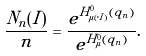Convert formula to latex. <formula><loc_0><loc_0><loc_500><loc_500>\frac { N _ { n } ( I ) } { n } = \frac { e ^ { H ^ { 0 } _ { \mu ( \cdot | I ) } ( q _ { n } ) } } { e ^ { H ^ { 0 } _ { \mu } ( q _ { n } ) } } .</formula> 